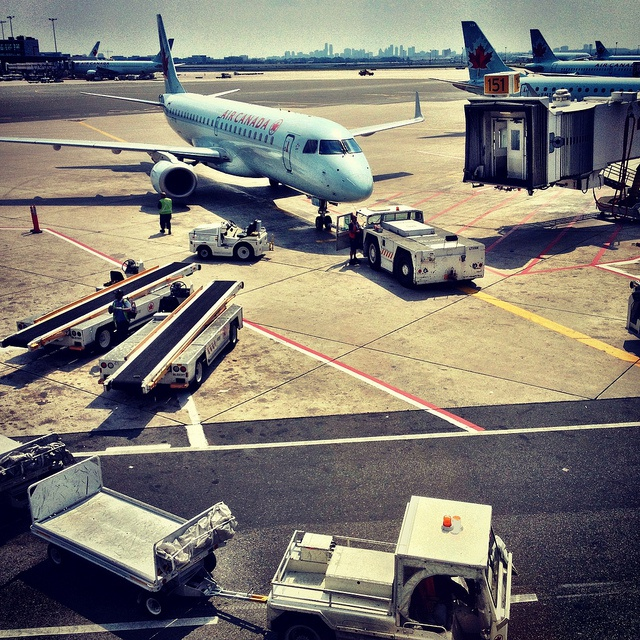Describe the objects in this image and their specific colors. I can see truck in gray, black, and lightyellow tones, airplane in gray, beige, teal, and darkgray tones, truck in gray, darkgray, black, and beige tones, airplane in gray, navy, blue, black, and beige tones, and car in gray, black, darkgray, and beige tones in this image. 